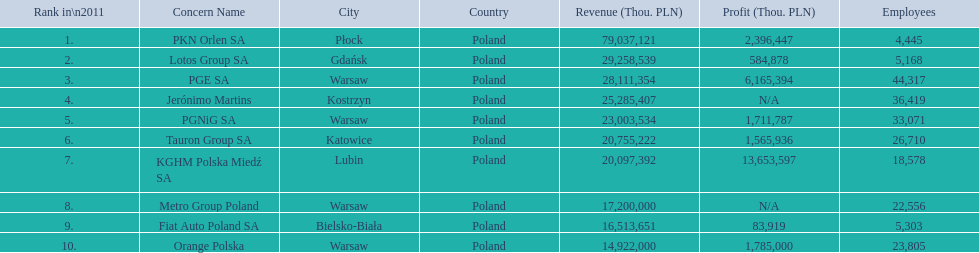What is the number of employees that work for pkn orlen sa in poland? 4,445. What number of employees work for lotos group sa? 5,168. How many people work for pgnig sa? 33,071. 